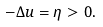<formula> <loc_0><loc_0><loc_500><loc_500>- \Delta u = \eta > 0 .</formula> 